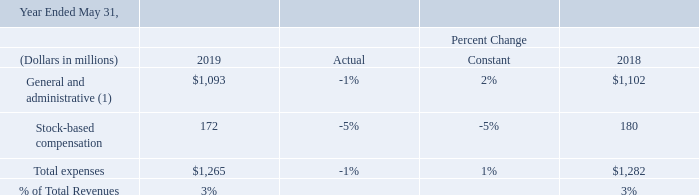General and Administrative Expenses: General and administrative expenses primarily consist of personnel related expenditures for IT, finance, legal and human resources support functions; and professional services fees.
(1) Excluding stock-based compensation
Excluding the effects of currency rate fluctuations, total general and administrative expenses increased in fiscal 2019 compared to fiscal 2018 primarily due to increased professional services fees
By how much less did the company spend for stock-based compensation in 2019 compared to 2018?
Answer scale should be: million. 180 -172 
Answer: 8. What is the average total expenses in 2018 and 2019?
Answer scale should be: million. (1,282 + 1,265)/2 
Answer: 1273.5. What was the average general and administrative expenses for 2019 and 2018? 
Answer scale should be: million. (1,093 + 1,102) / 2 
Answer: 1097.5. Which month did the financial year end in 2019? Year ended may 31. What are the components of general and administrative expenses? General and administrative expenses primarily consist of personnel related expenditures for it, finance, legal and human resources support functions; and professional services fees. Why did total general and administrative expenses increase in fiscal 2019 relative to fiscal 2018? Excluding the effects of currency rate fluctuations, total general and administrative expenses increased in fiscal 2019 compared to fiscal 2018 primarily due to increased professional services fees. 